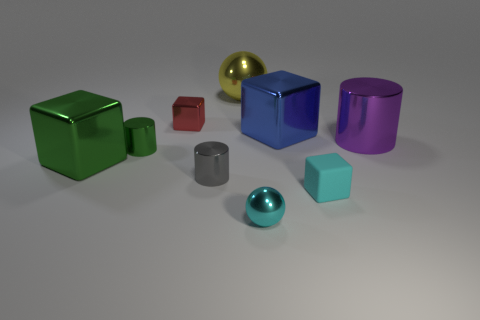Are there any other things that have the same material as the cyan cube?
Your response must be concise. No. What number of matte objects are tiny cyan cubes or big things?
Ensure brevity in your answer.  1. What is the material of the other tiny thing that is the same color as the rubber thing?
Your response must be concise. Metal. Are there fewer small cubes left of the small ball than purple metallic things behind the tiny cyan block?
Provide a short and direct response. No. What number of objects are rubber blocks or metallic blocks that are to the right of the gray shiny cylinder?
Offer a very short reply. 2. There is a red block that is the same size as the cyan metal object; what is its material?
Your answer should be very brief. Metal. Does the large purple cylinder have the same material as the tiny cyan cube?
Give a very brief answer. No. What color is the small thing that is both left of the rubber object and to the right of the large yellow sphere?
Your answer should be very brief. Cyan. Is the color of the metal cylinder to the right of the large blue block the same as the tiny shiny ball?
Make the answer very short. No. There is a purple shiny thing that is the same size as the blue shiny thing; what is its shape?
Provide a short and direct response. Cylinder. 